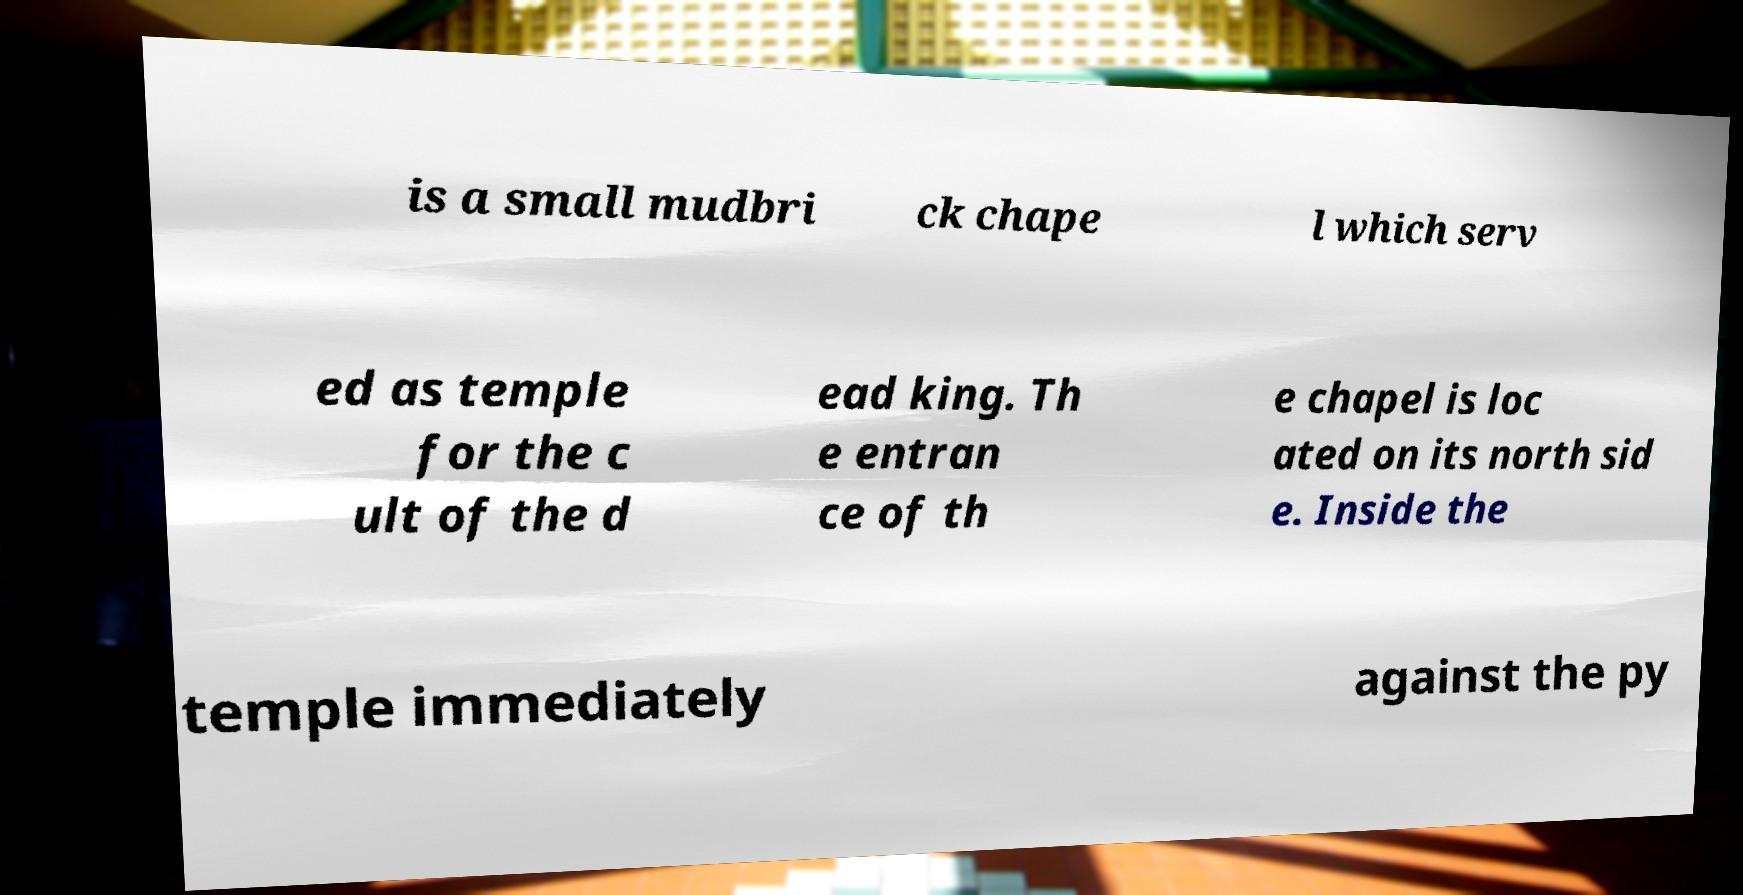There's text embedded in this image that I need extracted. Can you transcribe it verbatim? is a small mudbri ck chape l which serv ed as temple for the c ult of the d ead king. Th e entran ce of th e chapel is loc ated on its north sid e. Inside the temple immediately against the py 